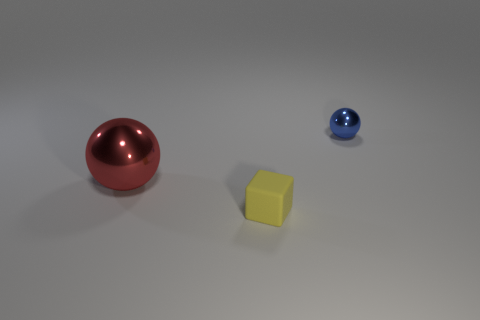Is there any other thing that has the same size as the red shiny thing?
Make the answer very short. No. Are there more small blue spheres to the left of the large thing than small matte blocks that are behind the yellow thing?
Offer a terse response. No. There is a yellow object that is the same size as the blue object; what shape is it?
Your response must be concise. Cube. What number of things are either red metallic objects or metal things behind the large red ball?
Offer a very short reply. 2. How many tiny matte blocks are in front of the red ball?
Your answer should be compact. 1. What is the color of the big thing that is made of the same material as the blue sphere?
Offer a very short reply. Red. How many metal things are either yellow objects or small red objects?
Your answer should be very brief. 0. Are the red sphere and the blue thing made of the same material?
Ensure brevity in your answer.  Yes. The tiny thing behind the small yellow object has what shape?
Keep it short and to the point. Sphere. Is there a small yellow matte block that is in front of the small thing that is behind the matte thing?
Give a very brief answer. Yes. 